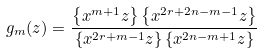<formula> <loc_0><loc_0><loc_500><loc_500>g _ { m } ( z ) = \frac { \left \{ x ^ { m + 1 } z \right \} \left \{ x ^ { 2 r + 2 n - m - 1 } z \right \} } { \left \{ x ^ { 2 r + m - 1 } z \right \} \left \{ x ^ { 2 n - m + 1 } z \right \} }</formula> 